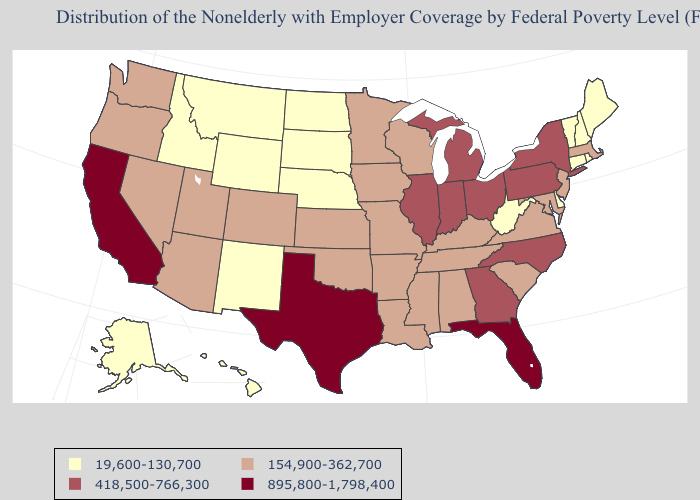What is the lowest value in states that border Virginia?
Quick response, please. 19,600-130,700. What is the lowest value in the USA?
Quick response, please. 19,600-130,700. Does Maine have the same value as Idaho?
Quick response, please. Yes. Name the states that have a value in the range 19,600-130,700?
Keep it brief. Alaska, Connecticut, Delaware, Hawaii, Idaho, Maine, Montana, Nebraska, New Hampshire, New Mexico, North Dakota, Rhode Island, South Dakota, Vermont, West Virginia, Wyoming. What is the value of Michigan?
Concise answer only. 418,500-766,300. How many symbols are there in the legend?
Short answer required. 4. Does California have the highest value in the West?
Concise answer only. Yes. Does Missouri have the highest value in the MidWest?
Answer briefly. No. Which states have the lowest value in the West?
Keep it brief. Alaska, Hawaii, Idaho, Montana, New Mexico, Wyoming. Name the states that have a value in the range 895,800-1,798,400?
Keep it brief. California, Florida, Texas. Does Illinois have a higher value than South Dakota?
Quick response, please. Yes. What is the highest value in the USA?
Give a very brief answer. 895,800-1,798,400. Which states have the lowest value in the USA?
Short answer required. Alaska, Connecticut, Delaware, Hawaii, Idaho, Maine, Montana, Nebraska, New Hampshire, New Mexico, North Dakota, Rhode Island, South Dakota, Vermont, West Virginia, Wyoming. Name the states that have a value in the range 418,500-766,300?
Give a very brief answer. Georgia, Illinois, Indiana, Michigan, New York, North Carolina, Ohio, Pennsylvania. 